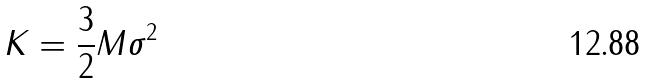<formula> <loc_0><loc_0><loc_500><loc_500>K = \frac { 3 } { 2 } M \sigma ^ { 2 }</formula> 